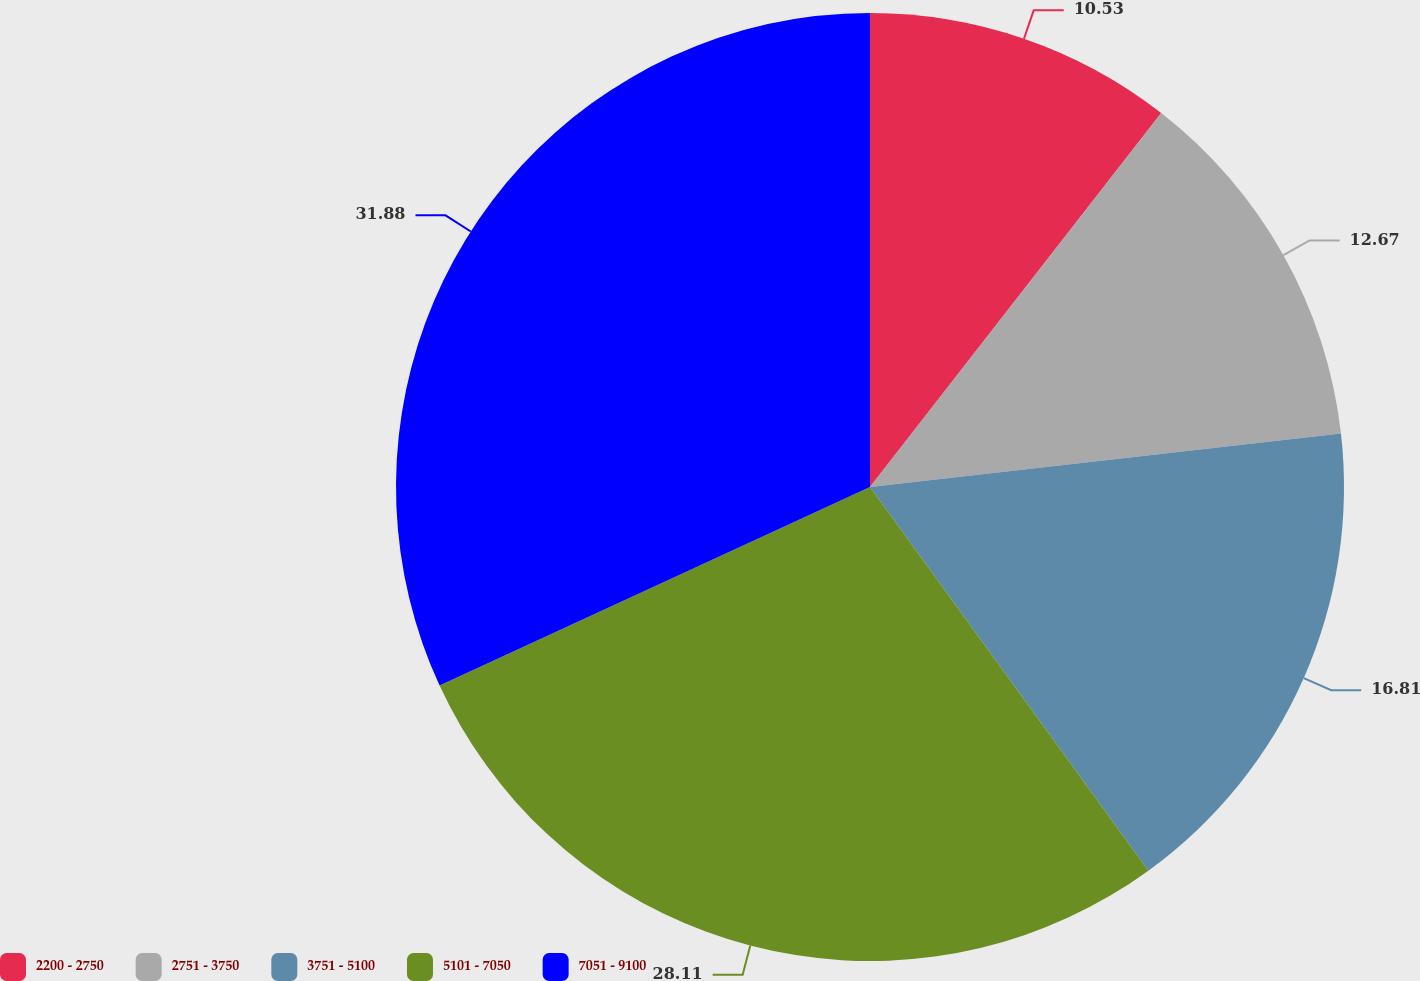Convert chart to OTSL. <chart><loc_0><loc_0><loc_500><loc_500><pie_chart><fcel>2200 - 2750<fcel>2751 - 3750<fcel>3751 - 5100<fcel>5101 - 7050<fcel>7051 - 9100<nl><fcel>10.53%<fcel>12.67%<fcel>16.81%<fcel>28.11%<fcel>31.88%<nl></chart> 